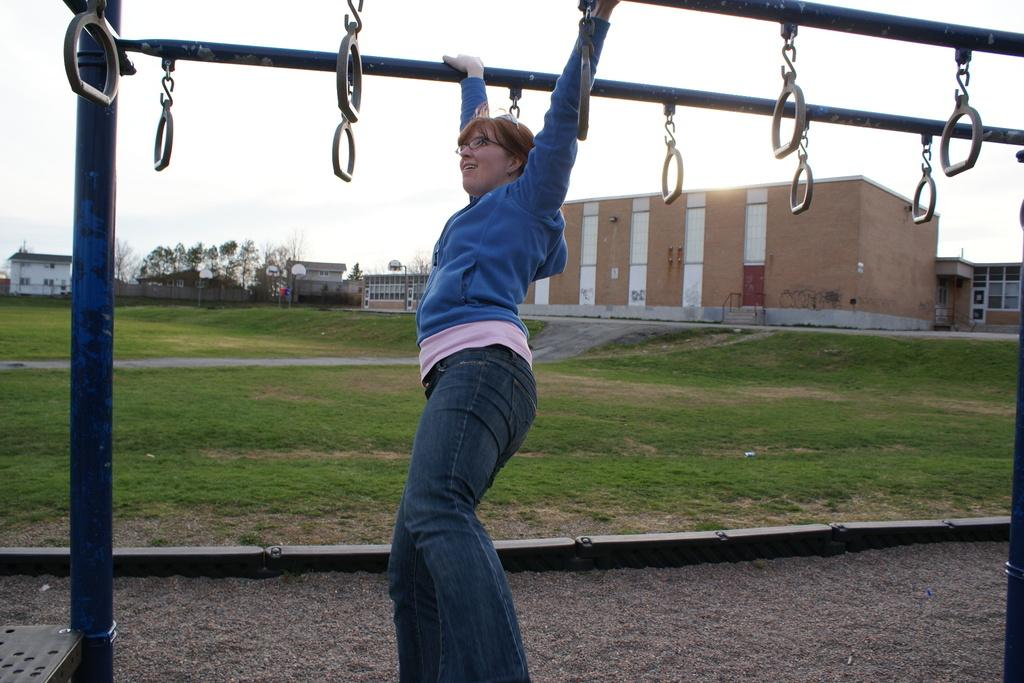What is the woman holding in the image? The woman is holding rods in the image. What are the hooks with handles used for in the image? The hooks with handles are used for holding or carrying something, but their specific purpose is not clear from the image. What type of terrain is visible in the image? There is grass and sand visible in the image. What can be seen in the background of the image? There are buildings, trees, boards, and a pole in the background of the image. What part of the natural environment is visible in the image? The sky is visible in the background of the image. What type of angle is being used to play chess in the image? There is no chess game or angle present in the image. What color is the chalk used to draw on the boards in the image? There is no chalk or drawing on the boards visible in the image. 